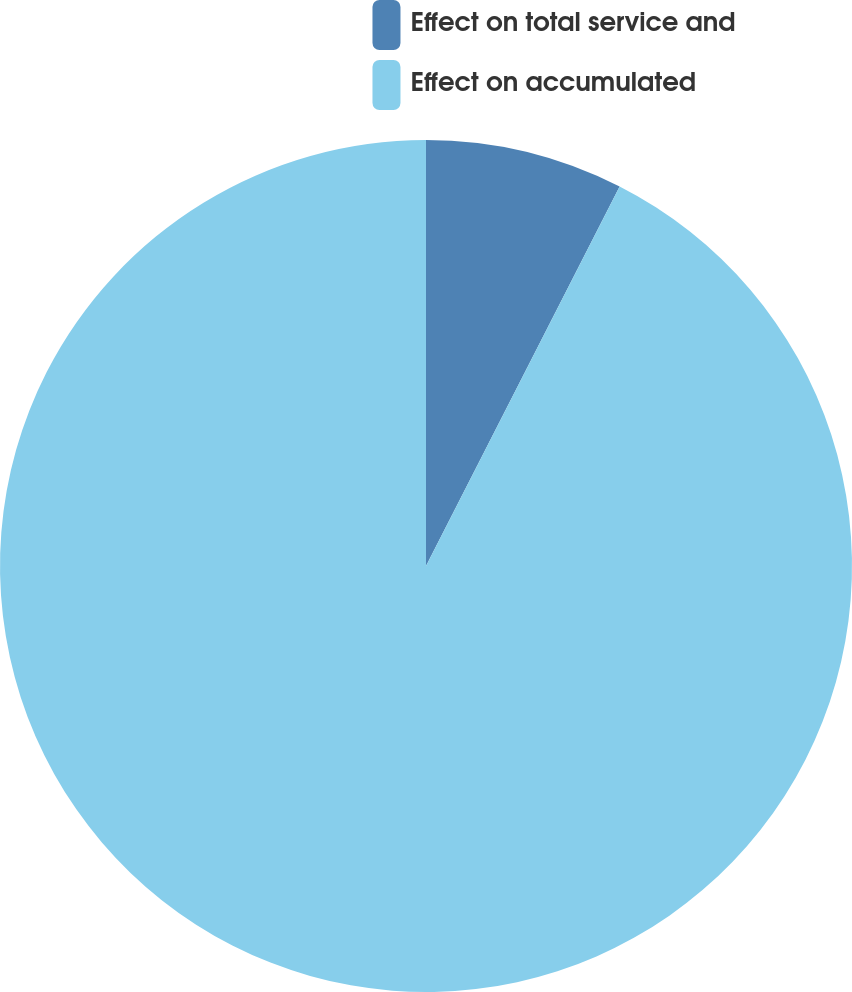Convert chart. <chart><loc_0><loc_0><loc_500><loc_500><pie_chart><fcel>Effect on total service and<fcel>Effect on accumulated<nl><fcel>7.51%<fcel>92.49%<nl></chart> 